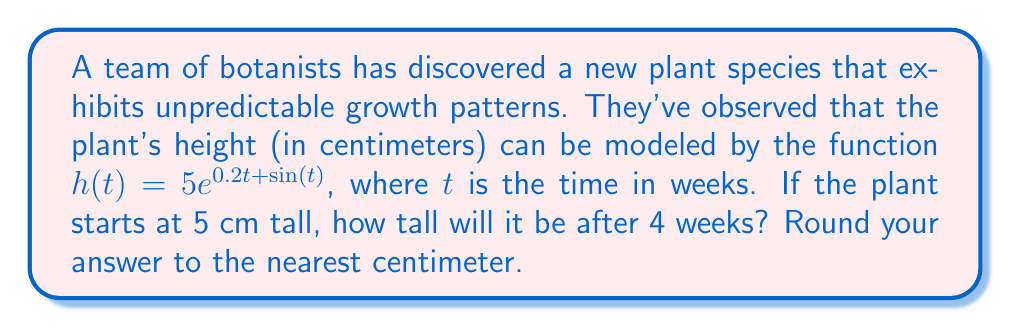Give your solution to this math problem. Let's approach this step-by-step:

1) We're given the function $h(t) = 5e^{0.2t + \sin(t)}$, where:
   - $h(t)$ is the height of the plant in centimeters
   - $t$ is the time in weeks
   - $e$ is the mathematical constant (approximately 2.71828)

2) We need to find $h(4)$, as we want to know the height after 4 weeks.

3) Let's substitute $t = 4$ into our function:

   $h(4) = 5e^{0.2(4) + \sin(4)}$

4) Simplify the exponent:
   
   $h(4) = 5e^{0.8 + \sin(4)}$

5) Calculate $\sin(4)$:
   $\sin(4) \approx -0.7568$ (using a calculator)

6) Substitute this value:

   $h(4) = 5e^{0.8 + (-0.7568)} = 5e^{0.0432}$

7) Calculate $e^{0.0432}$:
   $e^{0.0432} \approx 1.0441$ (using a calculator)

8) Multiply by 5:

   $h(4) = 5 * 1.0441 \approx 5.2205$

9) Rounding to the nearest centimeter:

   $h(4) \approx 5$ cm
Answer: 5 cm 